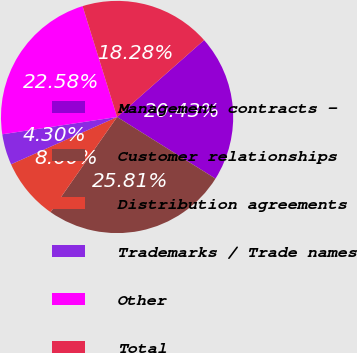<chart> <loc_0><loc_0><loc_500><loc_500><pie_chart><fcel>Management contracts -<fcel>Customer relationships<fcel>Distribution agreements<fcel>Trademarks / Trade names<fcel>Other<fcel>Total<nl><fcel>20.43%<fcel>25.81%<fcel>8.6%<fcel>4.3%<fcel>22.58%<fcel>18.28%<nl></chart> 